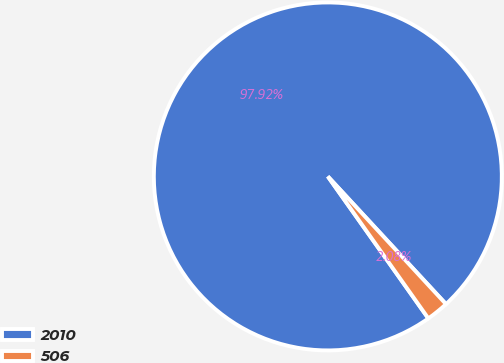<chart> <loc_0><loc_0><loc_500><loc_500><pie_chart><fcel>2010<fcel>506<nl><fcel>97.92%<fcel>2.08%<nl></chart> 